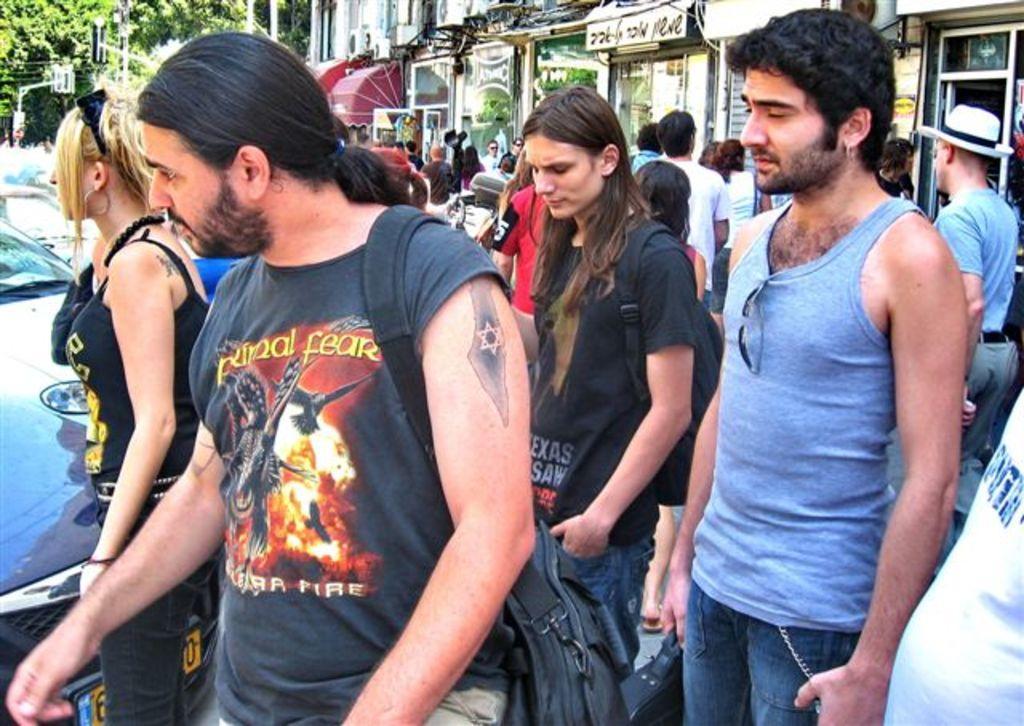In one or two sentences, can you explain what this image depicts? In the center of the image there is a person wearing a black color t-shirt and he is wearing a bag. Beside him there is a lady wearing black color dress. At the left side of the image there is a car. At the background of the image there are many people,there are many stores. At the right side of the image there is a person wearing a blue color vest. Beside him there is a girl wearing black color t-shirt and a bag. 